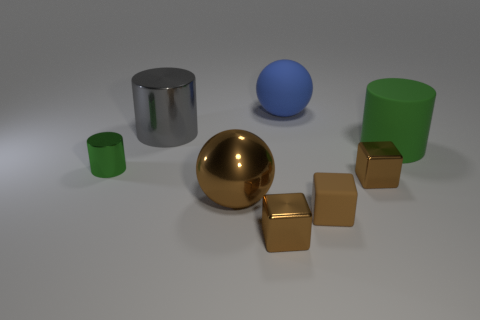How many cylinders are small yellow rubber objects or gray shiny objects?
Give a very brief answer. 1. What shape is the gray shiny thing?
Your response must be concise. Cylinder. Are there any green matte cylinders left of the big gray metallic thing?
Keep it short and to the point. No. Is the tiny green object made of the same material as the green cylinder that is behind the tiny green metallic cylinder?
Make the answer very short. No. There is a big blue rubber object that is behind the large gray metal object; does it have the same shape as the small brown rubber object?
Offer a terse response. No. What number of big gray cylinders have the same material as the gray object?
Your answer should be very brief. 0. What number of objects are either small shiny objects to the left of the big blue thing or big brown objects?
Offer a terse response. 3. What is the size of the brown metal sphere?
Provide a short and direct response. Large. The large sphere that is left of the matte thing that is behind the large green cylinder is made of what material?
Give a very brief answer. Metal. There is a brown block in front of the brown rubber thing; does it have the same size as the gray metallic cylinder?
Offer a terse response. No. 